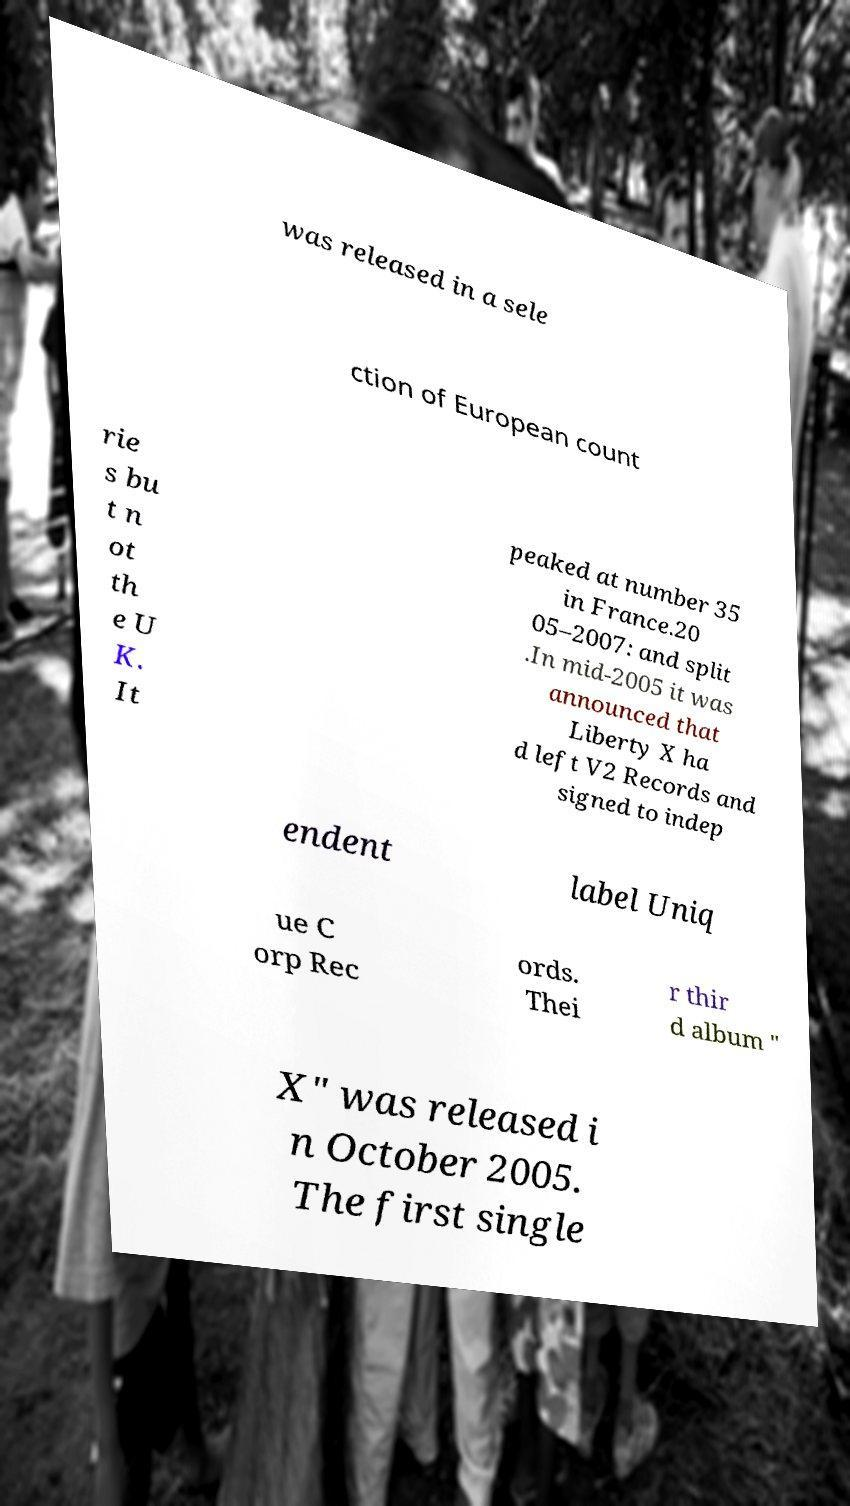Please identify and transcribe the text found in this image. was released in a sele ction of European count rie s bu t n ot th e U K. It peaked at number 35 in France.20 05–2007: and split .In mid-2005 it was announced that Liberty X ha d left V2 Records and signed to indep endent label Uniq ue C orp Rec ords. Thei r thir d album " X" was released i n October 2005. The first single 